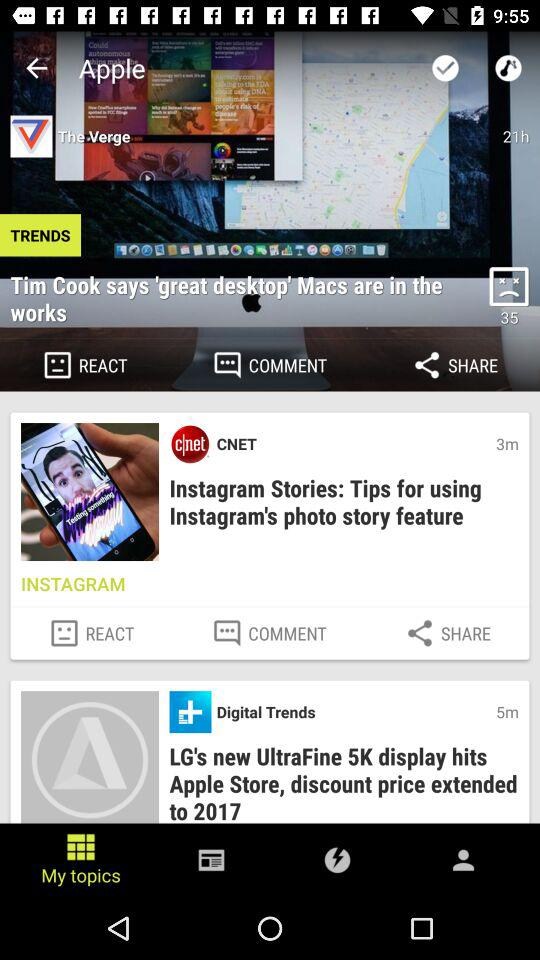What application is asking for permission? The application that is asking for permission is "Appy Geek". 